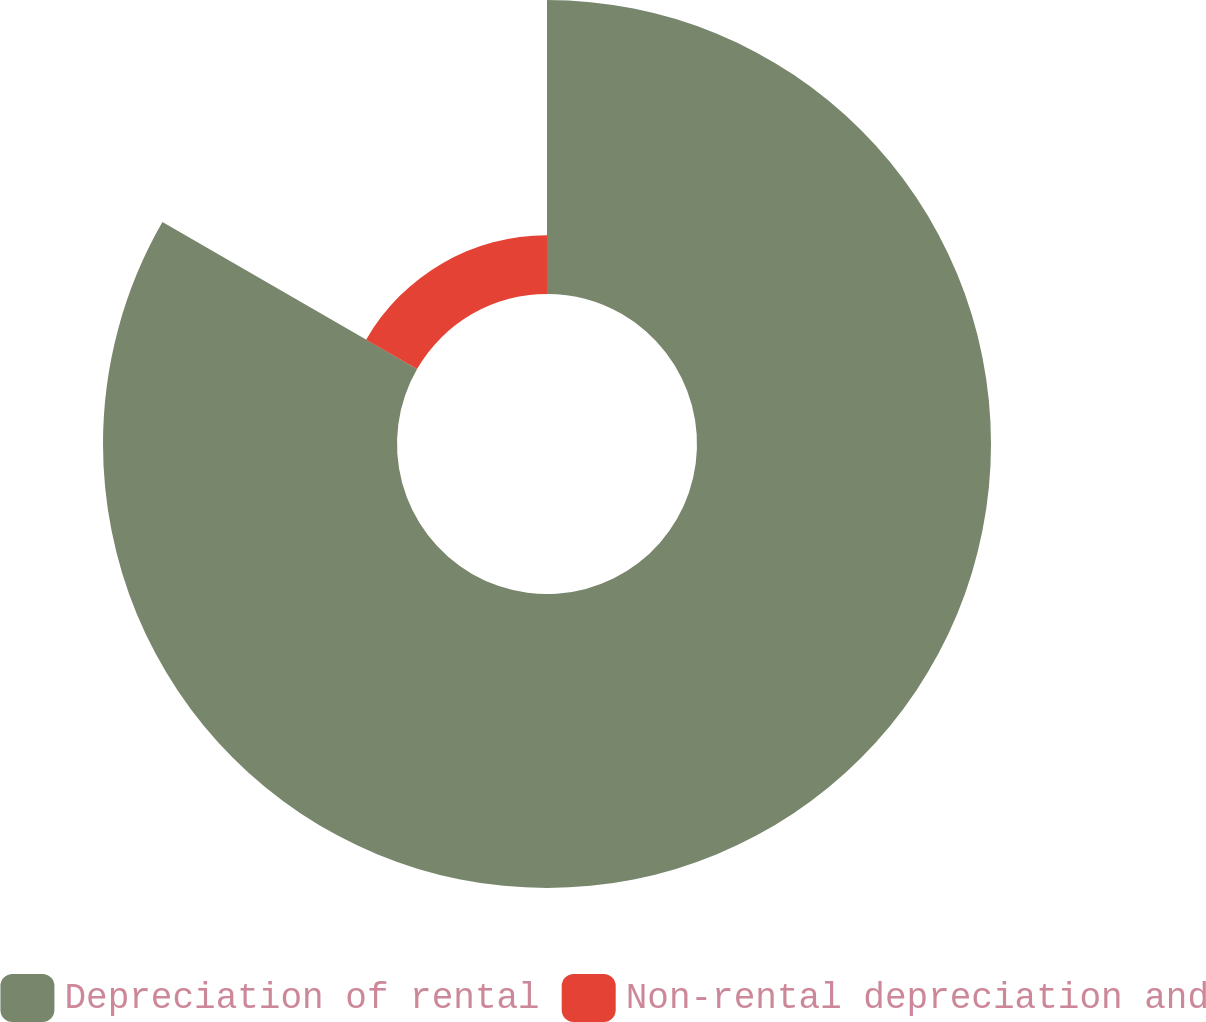<chart> <loc_0><loc_0><loc_500><loc_500><pie_chart><fcel>Depreciation of rental<fcel>Non-rental depreciation and<nl><fcel>83.33%<fcel>16.67%<nl></chart> 